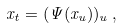Convert formula to latex. <formula><loc_0><loc_0><loc_500><loc_500>x _ { t } = ( \Psi ( x _ { u } ) ) _ { u } \, ,</formula> 